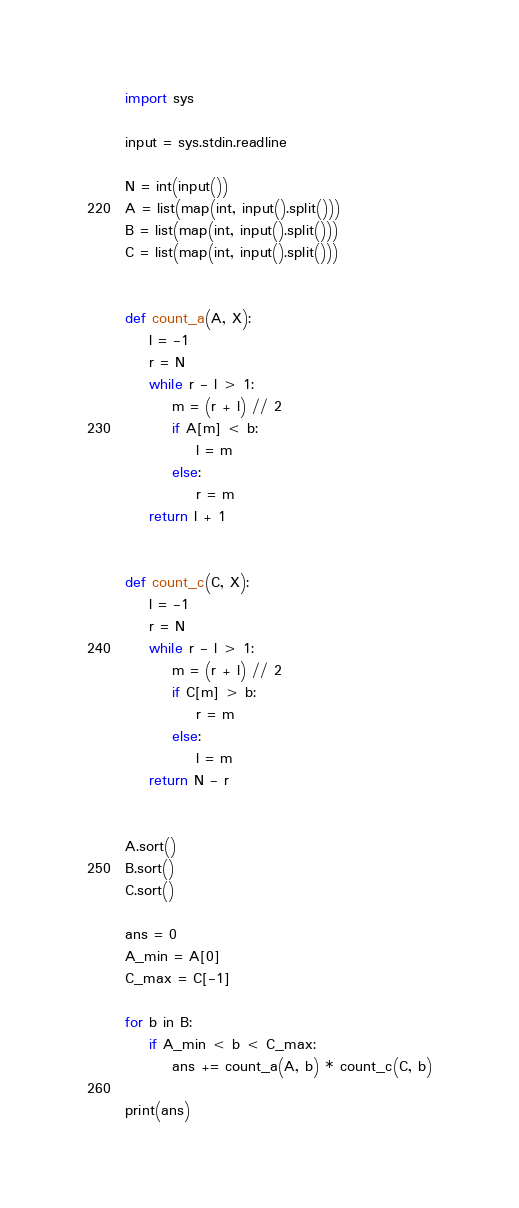<code> <loc_0><loc_0><loc_500><loc_500><_Python_>import sys

input = sys.stdin.readline

N = int(input())
A = list(map(int, input().split()))
B = list(map(int, input().split()))
C = list(map(int, input().split()))


def count_a(A, X):
    l = -1
    r = N
    while r - l > 1:
        m = (r + l) // 2
        if A[m] < b:
            l = m
        else:
            r = m
    return l + 1


def count_c(C, X):
    l = -1
    r = N
    while r - l > 1:
        m = (r + l) // 2
        if C[m] > b:
            r = m
        else:
            l = m
    return N - r


A.sort()
B.sort()
C.sort()

ans = 0
A_min = A[0]
C_max = C[-1]

for b in B:
    if A_min < b < C_max:
        ans += count_a(A, b) * count_c(C, b)

print(ans)
</code> 